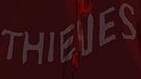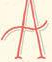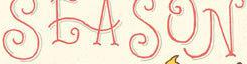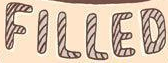What text is displayed in these images sequentially, separated by a semicolon? THIEVES; A; SEASON; FILLED 